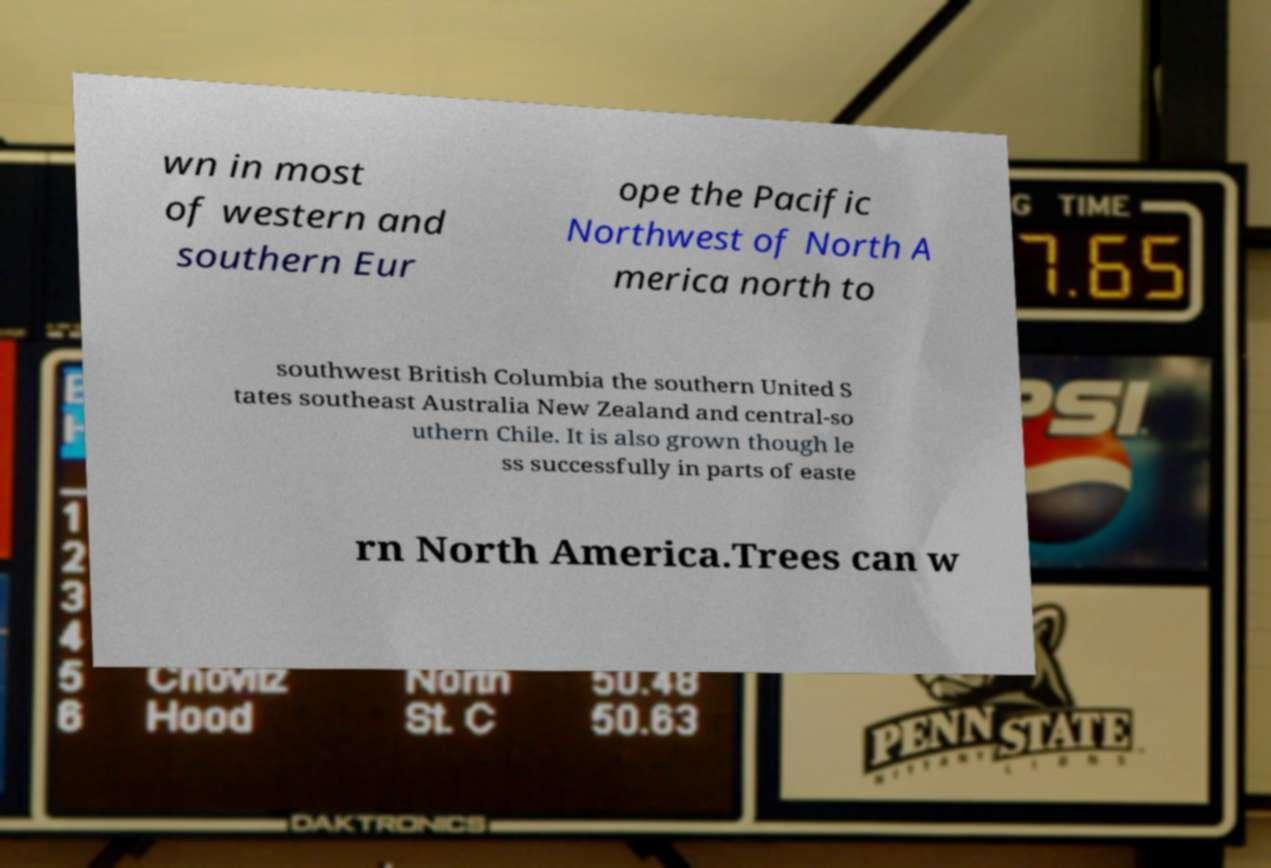What messages or text are displayed in this image? I need them in a readable, typed format. wn in most of western and southern Eur ope the Pacific Northwest of North A merica north to southwest British Columbia the southern United S tates southeast Australia New Zealand and central-so uthern Chile. It is also grown though le ss successfully in parts of easte rn North America.Trees can w 